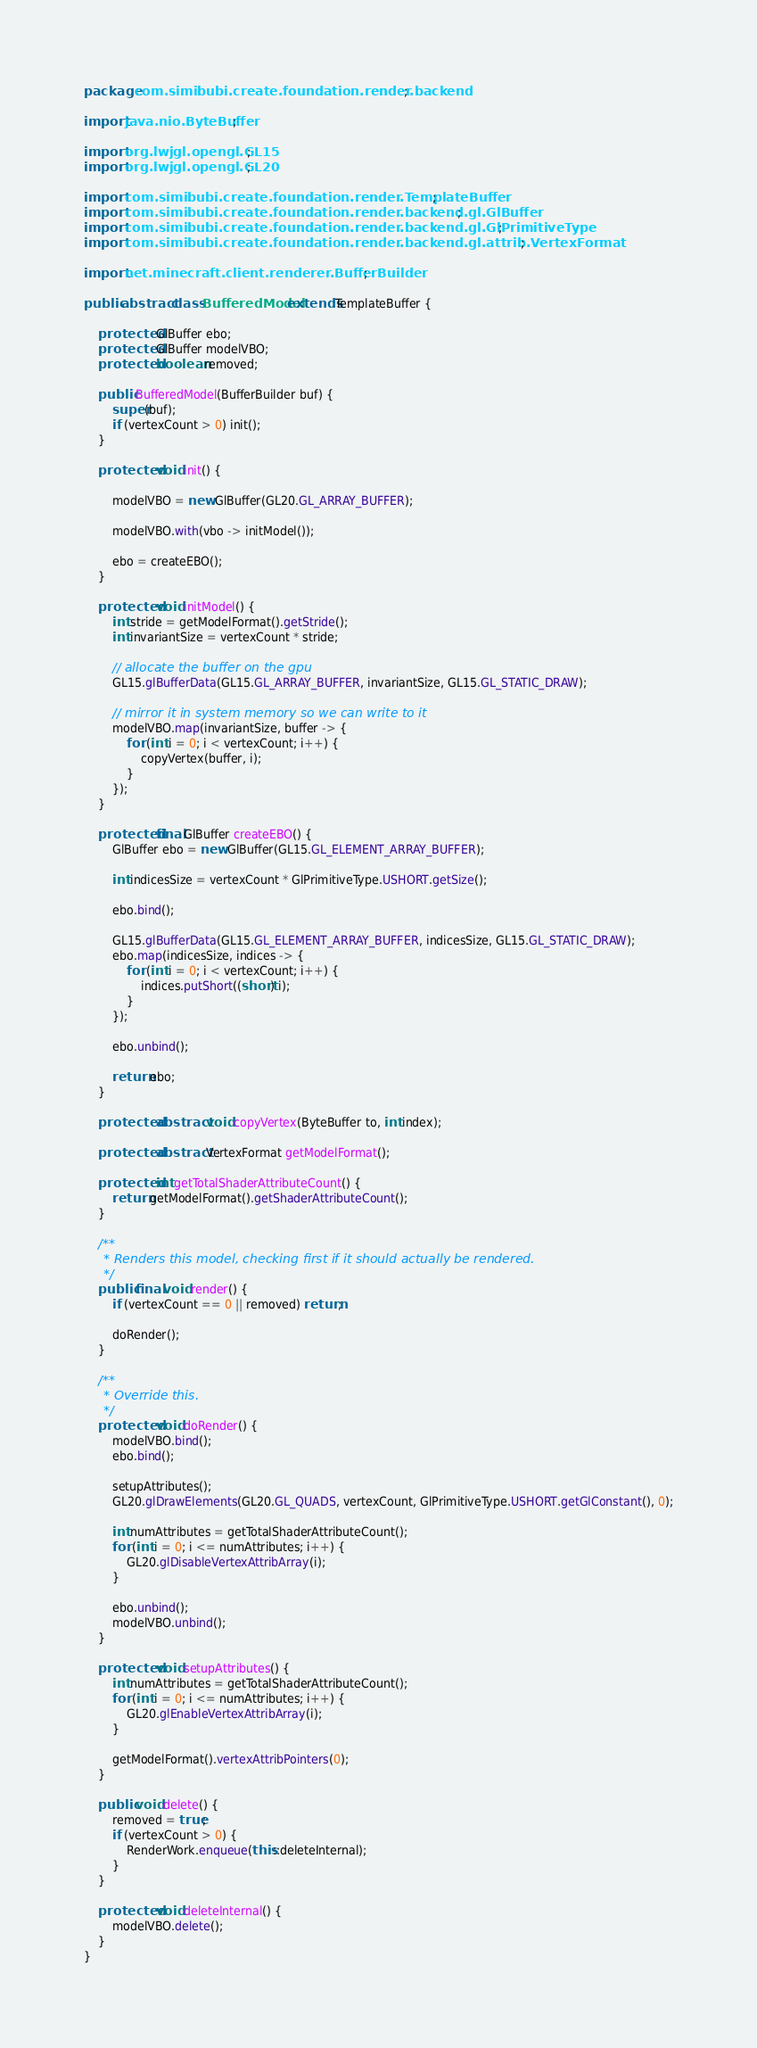<code> <loc_0><loc_0><loc_500><loc_500><_Java_>package com.simibubi.create.foundation.render.backend;

import java.nio.ByteBuffer;

import org.lwjgl.opengl.GL15;
import org.lwjgl.opengl.GL20;

import com.simibubi.create.foundation.render.TemplateBuffer;
import com.simibubi.create.foundation.render.backend.gl.GlBuffer;
import com.simibubi.create.foundation.render.backend.gl.GlPrimitiveType;
import com.simibubi.create.foundation.render.backend.gl.attrib.VertexFormat;

import net.minecraft.client.renderer.BufferBuilder;

public abstract class BufferedModel extends TemplateBuffer {

    protected GlBuffer ebo;
    protected GlBuffer modelVBO;
    protected boolean removed;

    public BufferedModel(BufferBuilder buf) {
        super(buf);
        if (vertexCount > 0) init();
    }

    protected void init() {

        modelVBO = new GlBuffer(GL20.GL_ARRAY_BUFFER);

        modelVBO.with(vbo -> initModel());

        ebo = createEBO();
    }

    protected void initModel() {
        int stride = getModelFormat().getStride();
        int invariantSize = vertexCount * stride;

        // allocate the buffer on the gpu
        GL15.glBufferData(GL15.GL_ARRAY_BUFFER, invariantSize, GL15.GL_STATIC_DRAW);

        // mirror it in system memory so we can write to it
        modelVBO.map(invariantSize, buffer -> {
            for (int i = 0; i < vertexCount; i++) {
                copyVertex(buffer, i);
            }
        });
    }

    protected final GlBuffer createEBO() {
        GlBuffer ebo = new GlBuffer(GL15.GL_ELEMENT_ARRAY_BUFFER);

        int indicesSize = vertexCount * GlPrimitiveType.USHORT.getSize();

        ebo.bind();

        GL15.glBufferData(GL15.GL_ELEMENT_ARRAY_BUFFER, indicesSize, GL15.GL_STATIC_DRAW);
        ebo.map(indicesSize, indices -> {
            for (int i = 0; i < vertexCount; i++) {
                indices.putShort((short) i);
            }
        });

        ebo.unbind();

        return ebo;
    }

    protected abstract void copyVertex(ByteBuffer to, int index);

    protected abstract VertexFormat getModelFormat();

    protected int getTotalShaderAttributeCount() {
        return getModelFormat().getShaderAttributeCount();
    }

    /**
     * Renders this model, checking first if it should actually be rendered.
     */
    public final void render() {
        if (vertexCount == 0 || removed) return;

        doRender();
    }

    /**
     * Override this.
     */
    protected void doRender() {
        modelVBO.bind();
        ebo.bind();

        setupAttributes();
        GL20.glDrawElements(GL20.GL_QUADS, vertexCount, GlPrimitiveType.USHORT.getGlConstant(), 0);

        int numAttributes = getTotalShaderAttributeCount();
        for (int i = 0; i <= numAttributes; i++) {
            GL20.glDisableVertexAttribArray(i);
        }

        ebo.unbind();
        modelVBO.unbind();
    }

    protected void setupAttributes() {
        int numAttributes = getTotalShaderAttributeCount();
        for (int i = 0; i <= numAttributes; i++) {
            GL20.glEnableVertexAttribArray(i);
        }

        getModelFormat().vertexAttribPointers(0);
    }

    public void delete() {
        removed = true;
        if (vertexCount > 0) {
            RenderWork.enqueue(this::deleteInternal);
        }
    }

    protected void deleteInternal() {
        modelVBO.delete();
    }
}
</code> 